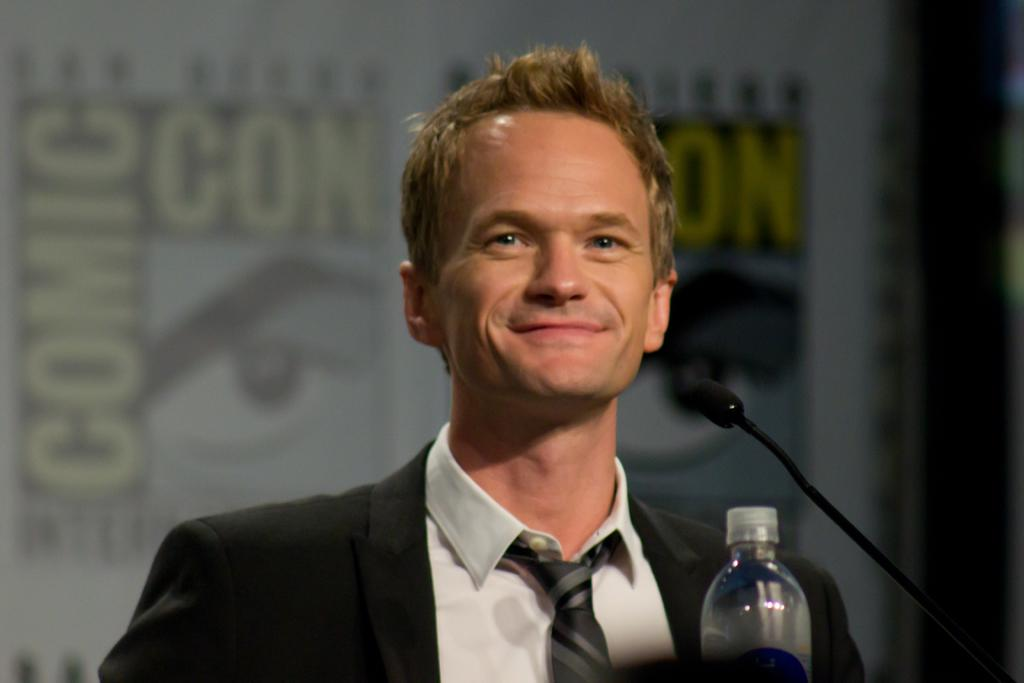Who is present in the image? There is a man in the image. What is the man wearing? The man is wearing a black suit. What is the man's facial expression? The man is smiling. What object can be seen near the man? There is a microphone (mike) in the image. What other item is visible in the image? There is a bottle in the image. What type of eggnog is the man holding in the image? There is no eggnog present in the image; it only shows a man wearing a black suit, smiling, with a microphone and a bottle nearby. 